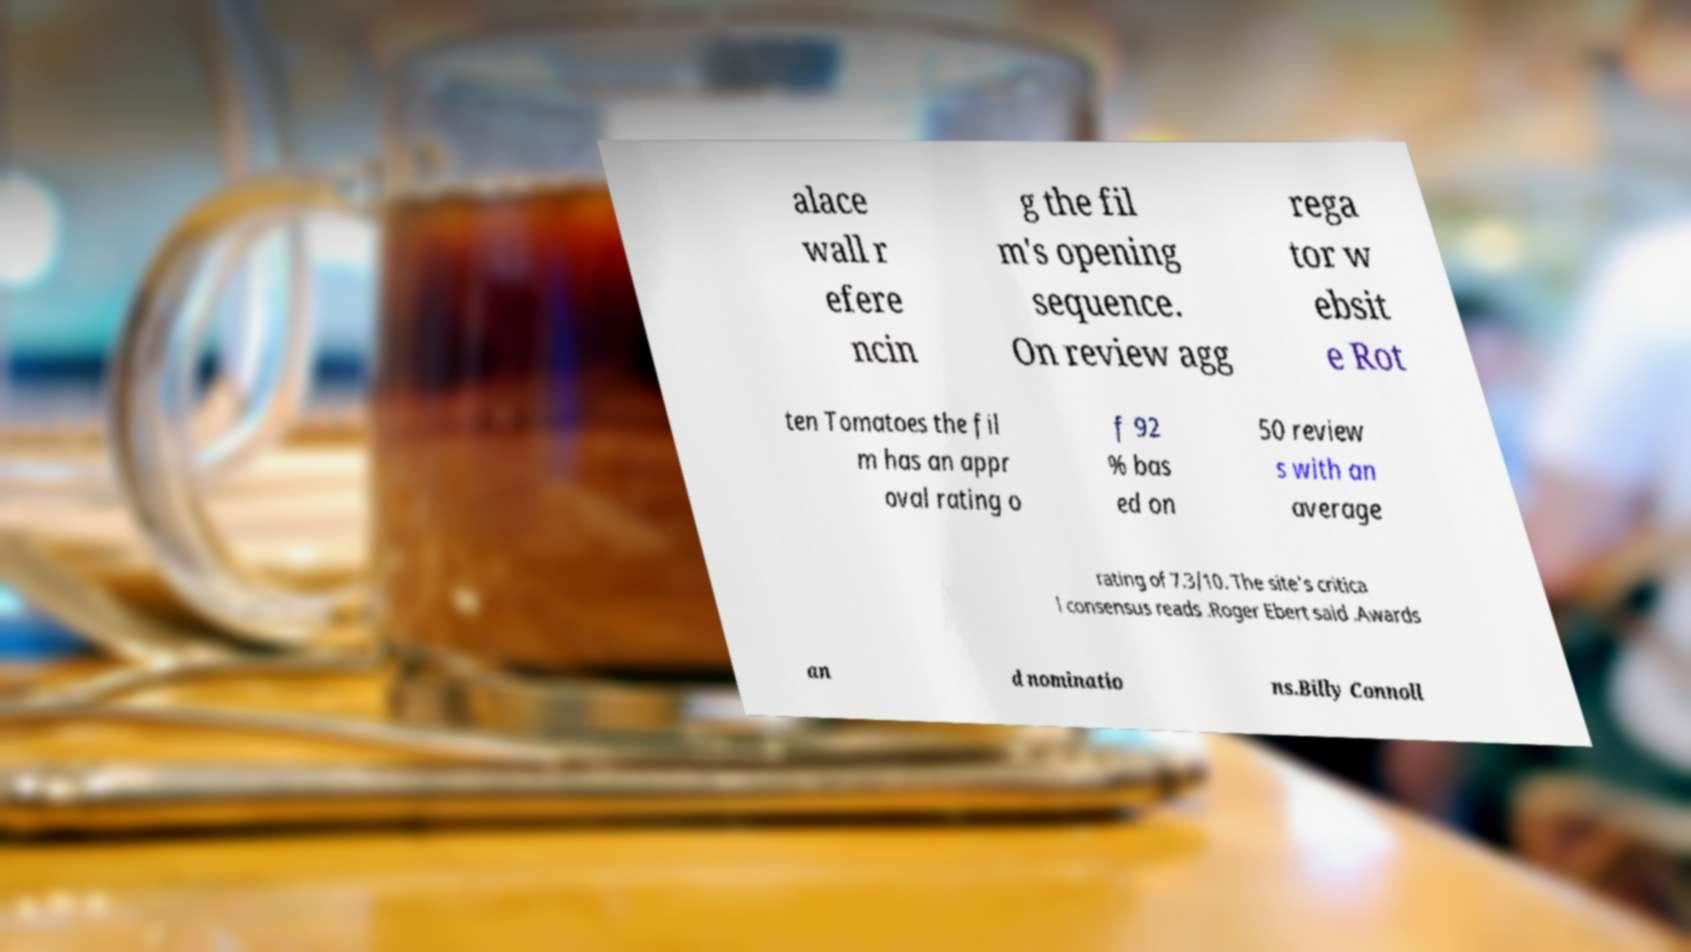Can you read and provide the text displayed in the image?This photo seems to have some interesting text. Can you extract and type it out for me? alace wall r efere ncin g the fil m's opening sequence. On review agg rega tor w ebsit e Rot ten Tomatoes the fil m has an appr oval rating o f 92 % bas ed on 50 review s with an average rating of 7.3/10. The site's critica l consensus reads .Roger Ebert said .Awards an d nominatio ns.Billy Connoll 